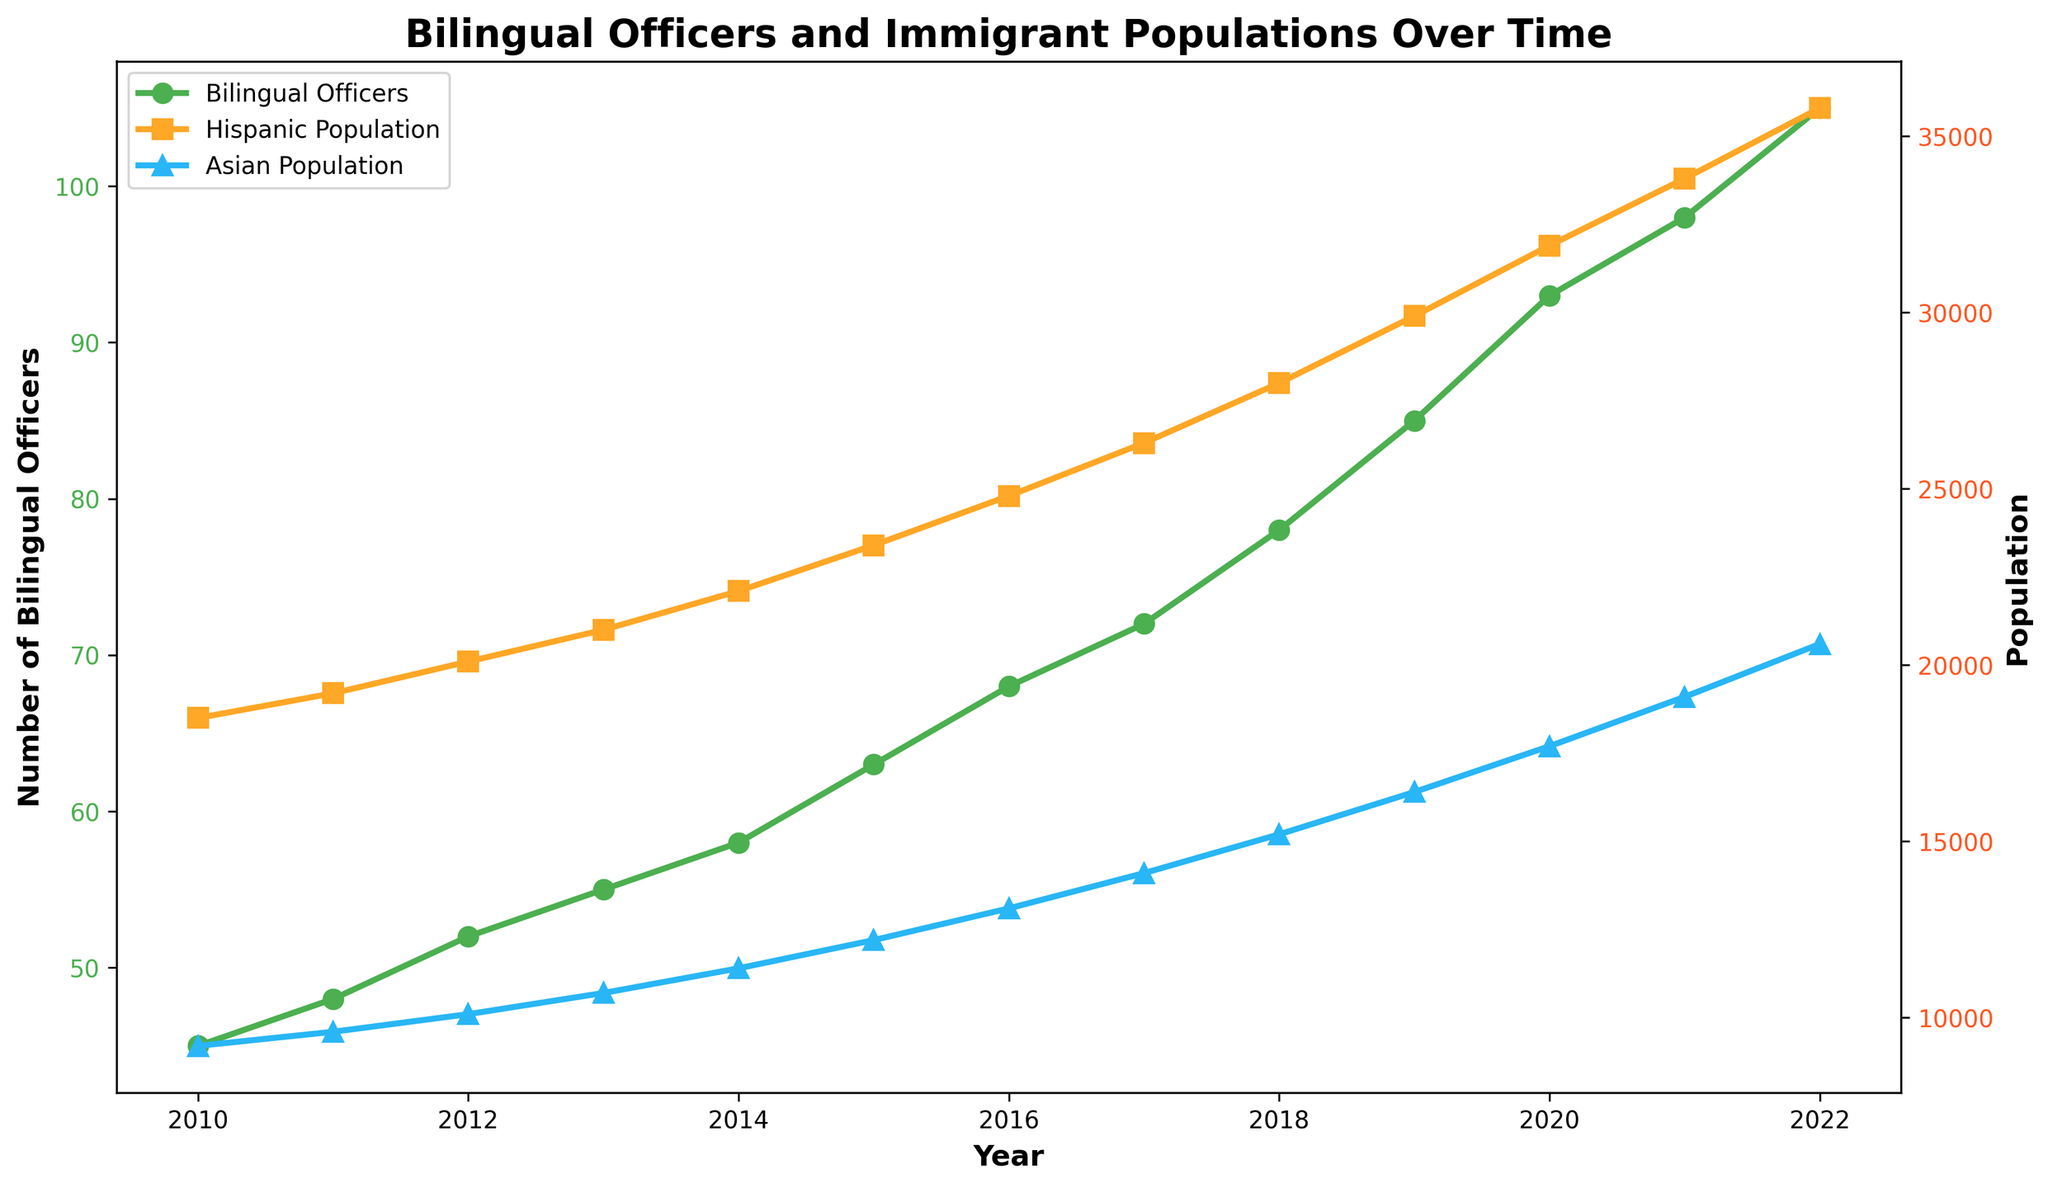What trend can be observed in the number of bilingual officers from 2010 to 2022? The graph shows an upward trend in the number of bilingual officers, steadily increasing each year from 45 in 2010 to 105 in 2022.
Answer: Increasing By how much did the Hispanic population grow between 2010 and 2022? To find the growth, subtract the Hispanic population in 2010 from that in 2022: 35800 - 18500 = 17300.
Answer: 17300 Which year saw the greatest increase in bilingual officers compared to the previous year? To determine the greatest annual increase, examine the differences year-to-year: The largest increase is from 2021 to 2022, where the number of bilingual officers increased from 98 to 105, a growth of 7.
Answer: 2022 How did the trend in the Asian population correlate with the trend in the number of bilingual officers? Both the number of bilingual officers and the Asian population show a positive, upward trend over the years, suggesting a correlation between the increasing number of Asian immigrants and the employment of more bilingual officers.
Answer: Positive correlation What is the average number of bilingual officers employed per year from 2010 to 2022? Sum the number of bilingual officers from 2010 to 2022 and divide by the number of years: (45 + 48 + 52 + 55 + 58 + 63 + 68 + 72 + 78 + 85 + 93 + 98 + 105) / 13 = 68.31
Answer: 68.31 In 2015, how did the Hispanic population compare to the Asian population? From the graph, in 2015, the Hispanic population was 23400 and the Asian population was 12200, indicating the Hispanic population was larger.
Answer: Larger Which population grew faster between 2016 and 2022, Hispanic or Asian? Calculate the increase for both populations: Hispanic growth from 2016 to 2022 is 35800 - 24800 = 11000, and Asian growth is 20600 - 13100 = 7500, indicating that the Hispanic population grew faster.
Answer: Hispanic What was the percent increase in the number of bilingual officers from 2010 to 2022? The percent increase is calculated as ((105 - 45) / 45) * 100 = 133.33%.
Answer: 133.33% In which year did the bilingual officers reach 68? According to the data and graph, bilingual officers reached 68 in the year 2016.
Answer: 2016 